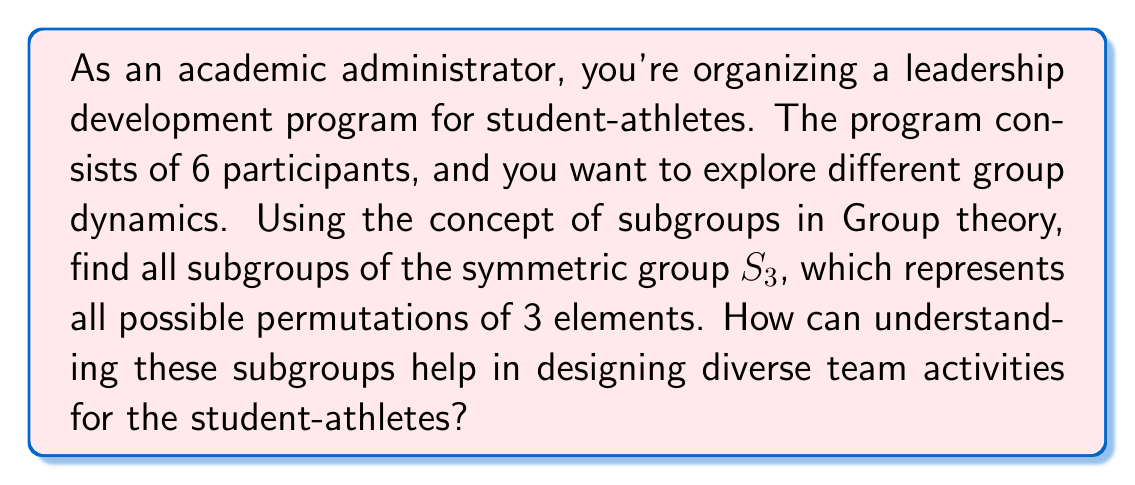Could you help me with this problem? Let's approach this step-by-step:

1) First, we need to understand what $S_3$ is:
   $S_3$ is the symmetric group of degree 3, which contains all permutations of 3 elements.
   $S_3 = \{e, (12), (13), (23), (123), (132)\}$, where $e$ is the identity permutation.

2) To find all subgroups, we need to check all possible combinations of elements that form a group:

   a) The trivial subgroup: $\{e\}$ is always a subgroup.

   b) The whole group $S_3$ is always a subgroup of itself.

   c) Cyclic subgroups generated by each element:
      - $\langle (12) \rangle = \{e, (12)\}$
      - $\langle (13) \rangle = \{e, (13)\}$
      - $\langle (23) \rangle = \{e, (23)\}$
      - $\langle (123) \rangle = \{e, (123), (132)\}$
      - $\langle (132) \rangle = \{e, (123), (132)\}$ (same as above)

   d) The subgroup $A_3 = \{e, (123), (132)\}$, which is the alternating group of degree 3.

3) Therefore, the subgroups of $S_3$ are:
   $\{e\}$, $\{e, (12)\}$, $\{e, (13)\}$, $\{e, (23)\}$, $\{e, (123), (132)\}$, and $S_3$ itself.

Understanding these subgroups can help in designing diverse team activities for student-athletes:

1) The trivial subgroup $\{e\}$ represents individual work, essential for personal growth.
2) The order-2 subgroups $\{e, (12)\}$, $\{e, (13)\}$, $\{e, (23)\}$ represent pair activities, fostering one-on-one interactions.
3) The order-3 subgroup $\{e, (123), (132)\}$ represents activities for groups of three, encouraging small group dynamics.
4) The full group $S_3$ represents activities involving all six participants, promoting full team collaboration.

This structure allows for a balanced program that develops individual skills, pair relationships, small group cooperation, and full team synergy.
Answer: The subgroups of $S_3$ are:
$$\{e\}, \{e, (12)\}, \{e, (13)\}, \{e, (23)\}, \{e, (123), (132)\}, S_3$$
These subgroups can be used to design a variety of team activities that promote individual growth, pair interactions, small group dynamics, and full team collaboration. 